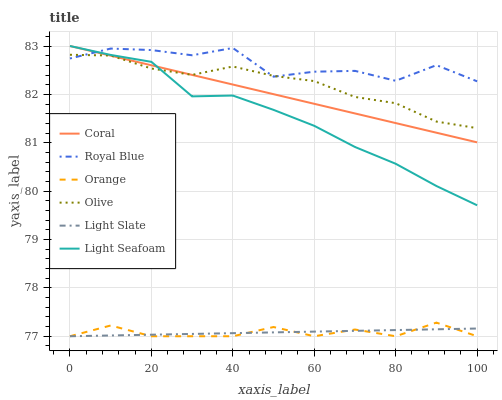Does Coral have the minimum area under the curve?
Answer yes or no. No. Does Coral have the maximum area under the curve?
Answer yes or no. No. Is Light Slate the smoothest?
Answer yes or no. No. Is Light Slate the roughest?
Answer yes or no. No. Does Coral have the lowest value?
Answer yes or no. No. Does Light Slate have the highest value?
Answer yes or no. No. Is Light Slate less than Olive?
Answer yes or no. Yes. Is Light Seafoam greater than Light Slate?
Answer yes or no. Yes. Does Light Slate intersect Olive?
Answer yes or no. No. 